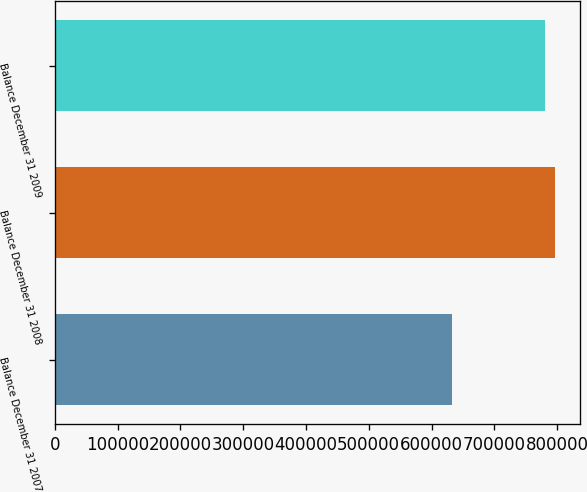Convert chart. <chart><loc_0><loc_0><loc_500><loc_500><bar_chart><fcel>Balance December 31 2007<fcel>Balance December 31 2008<fcel>Balance December 31 2009<nl><fcel>633030<fcel>796913<fcel>781364<nl></chart> 